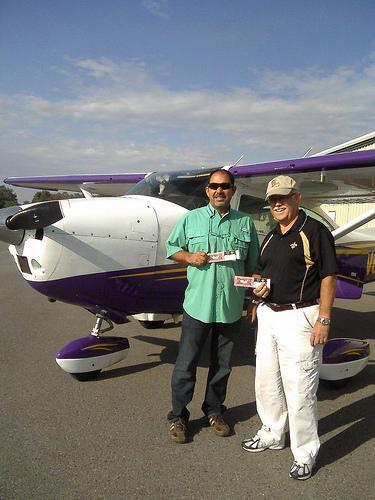How many propellers does the plane have?
Give a very brief answer. 1. 